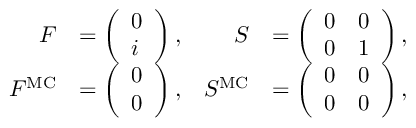<formula> <loc_0><loc_0><loc_500><loc_500>\begin{array} { r l r l } { F } & { = \left ( \begin{array} { l } { 0 } \\ { i } \end{array} \right ) , } & { S } & { = \left ( \begin{array} { l l } { 0 } & { 0 } \\ { 0 } & { 1 } \end{array} \right ) , } \\ { F ^ { M C } } & { = \left ( \begin{array} { l } { 0 } \\ { 0 } \end{array} \right ) , } & { S ^ { M C } } & { = \left ( \begin{array} { l l } { 0 } & { 0 } \\ { 0 } & { 0 } \end{array} \right ) , } \end{array}</formula> 